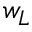Convert formula to latex. <formula><loc_0><loc_0><loc_500><loc_500>w _ { L }</formula> 